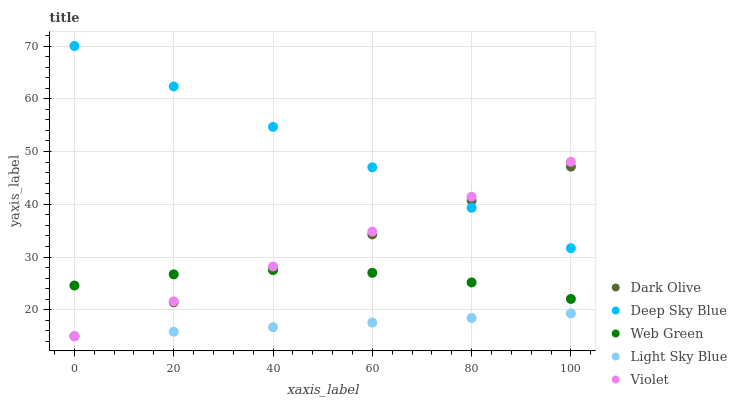Does Light Sky Blue have the minimum area under the curve?
Answer yes or no. Yes. Does Deep Sky Blue have the maximum area under the curve?
Answer yes or no. Yes. Does Dark Olive have the minimum area under the curve?
Answer yes or no. No. Does Dark Olive have the maximum area under the curve?
Answer yes or no. No. Is Light Sky Blue the smoothest?
Answer yes or no. Yes. Is Web Green the roughest?
Answer yes or no. Yes. Is Dark Olive the smoothest?
Answer yes or no. No. Is Dark Olive the roughest?
Answer yes or no. No. Does Violet have the lowest value?
Answer yes or no. Yes. Does Web Green have the lowest value?
Answer yes or no. No. Does Deep Sky Blue have the highest value?
Answer yes or no. Yes. Does Dark Olive have the highest value?
Answer yes or no. No. Is Light Sky Blue less than Deep Sky Blue?
Answer yes or no. Yes. Is Deep Sky Blue greater than Web Green?
Answer yes or no. Yes. Does Deep Sky Blue intersect Dark Olive?
Answer yes or no. Yes. Is Deep Sky Blue less than Dark Olive?
Answer yes or no. No. Is Deep Sky Blue greater than Dark Olive?
Answer yes or no. No. Does Light Sky Blue intersect Deep Sky Blue?
Answer yes or no. No. 